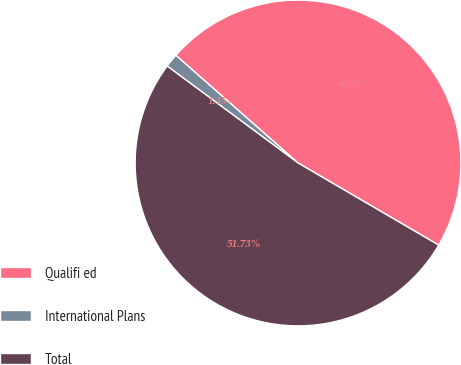Convert chart. <chart><loc_0><loc_0><loc_500><loc_500><pie_chart><fcel>Qualifi ed<fcel>International Plans<fcel>Total<nl><fcel>46.92%<fcel>1.35%<fcel>51.73%<nl></chart> 